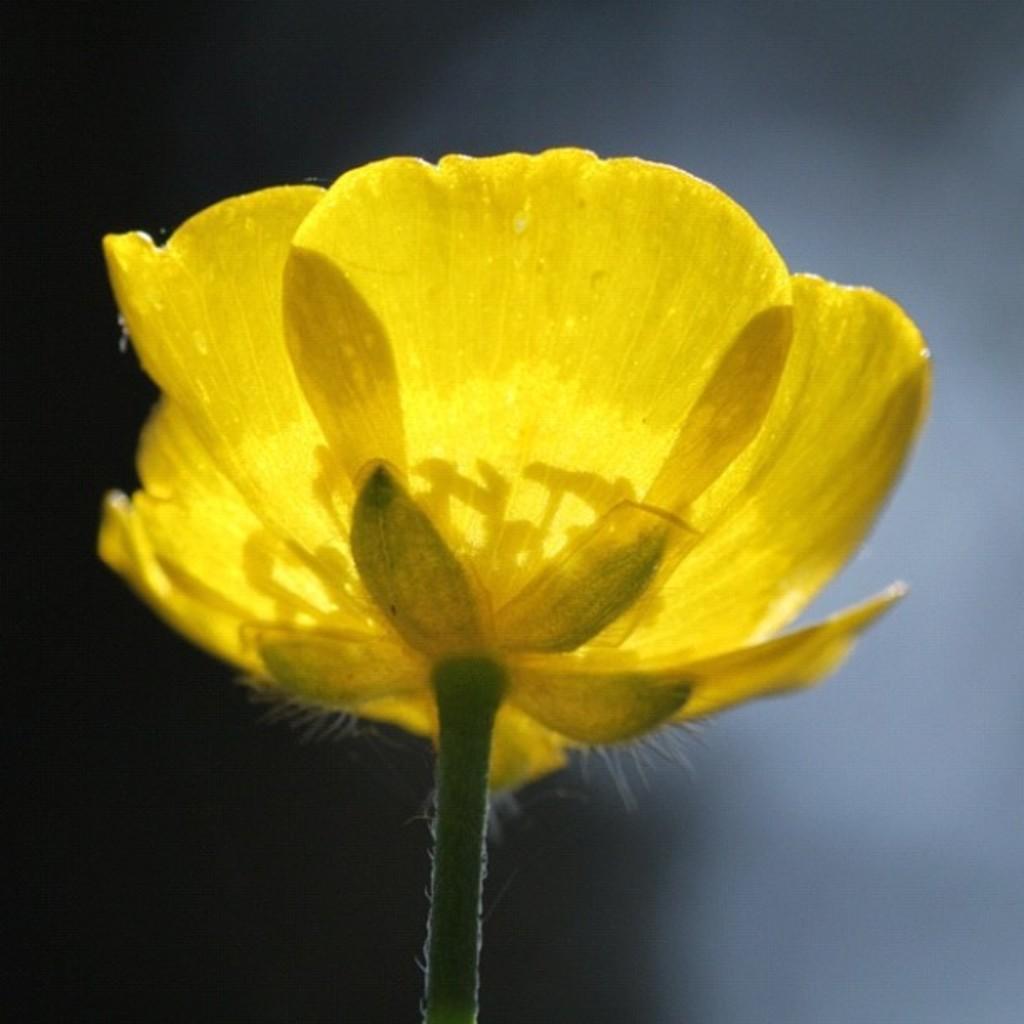In one or two sentences, can you explain what this image depicts? In the foreground of this image, there is a yellow color flower and the background image is blur. 